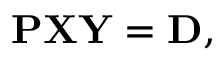Convert formula to latex. <formula><loc_0><loc_0><loc_500><loc_500>\begin{array} { r } { P X Y = D , } \end{array}</formula> 